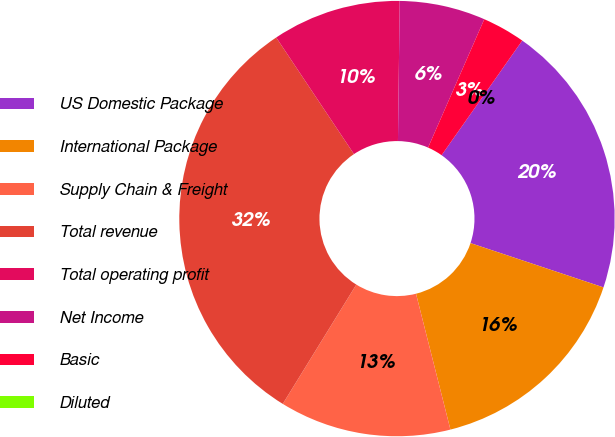Convert chart. <chart><loc_0><loc_0><loc_500><loc_500><pie_chart><fcel>US Domestic Package<fcel>International Package<fcel>Supply Chain & Freight<fcel>Total revenue<fcel>Total operating profit<fcel>Net Income<fcel>Basic<fcel>Diluted<nl><fcel>20.36%<fcel>15.93%<fcel>12.74%<fcel>31.85%<fcel>9.56%<fcel>6.37%<fcel>3.19%<fcel>0.0%<nl></chart> 